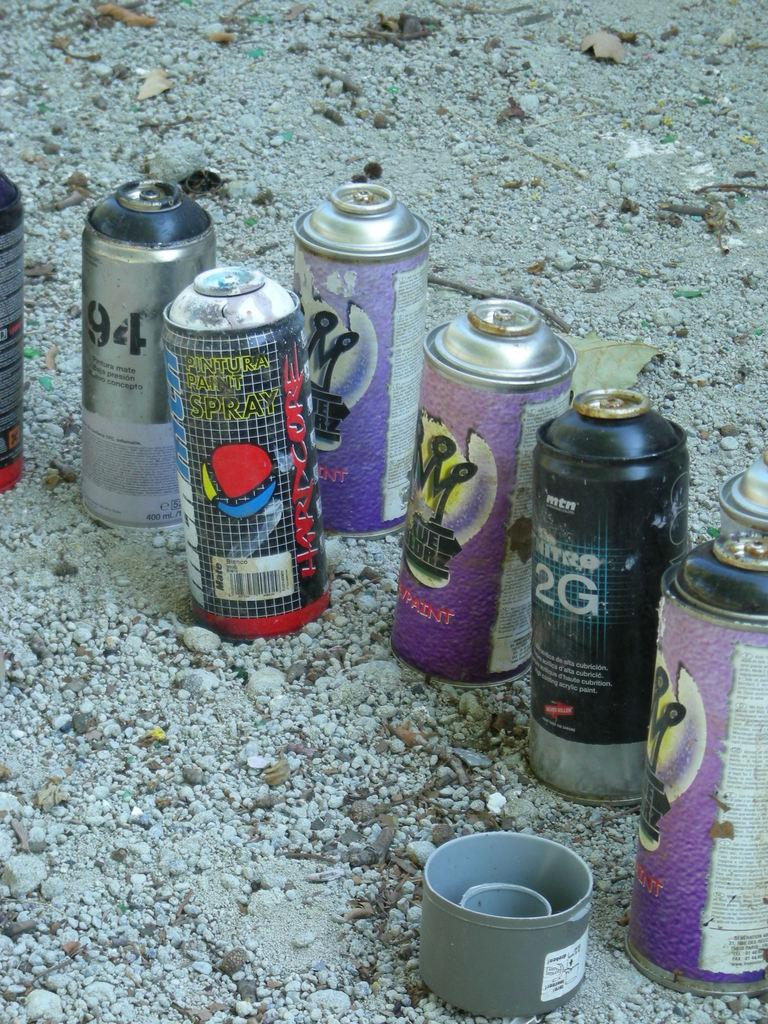<image>
Summarize the visual content of the image. Cans of spraypaint with one that has the number 94 on it. 